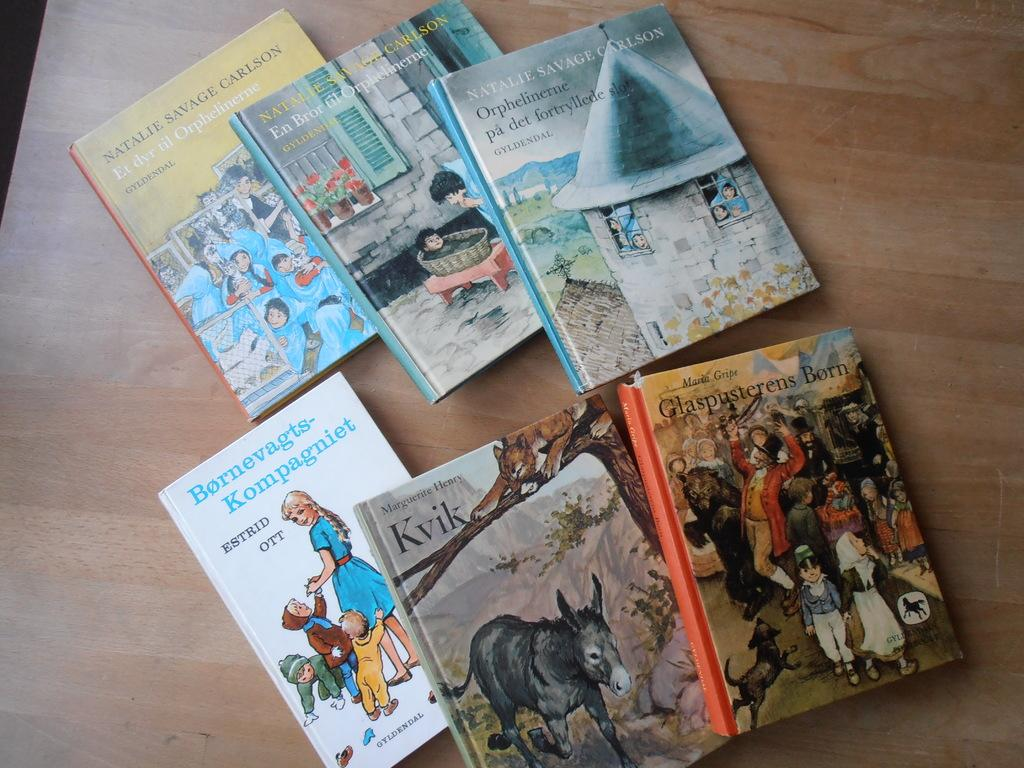<image>
Write a terse but informative summary of the picture. Six children's books spread out including one by Natalie Savage Carlson. 